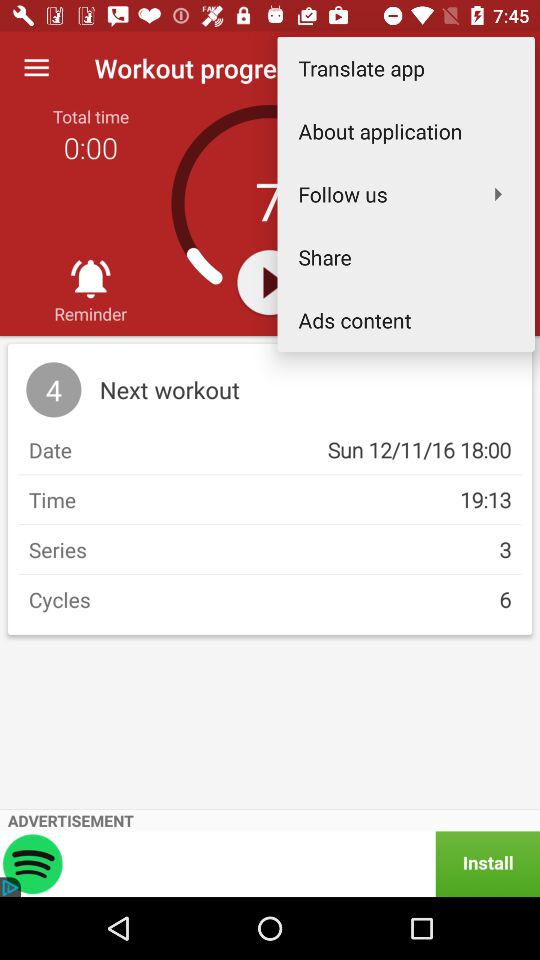What's the "Time"? The "Time" is 19:13. 